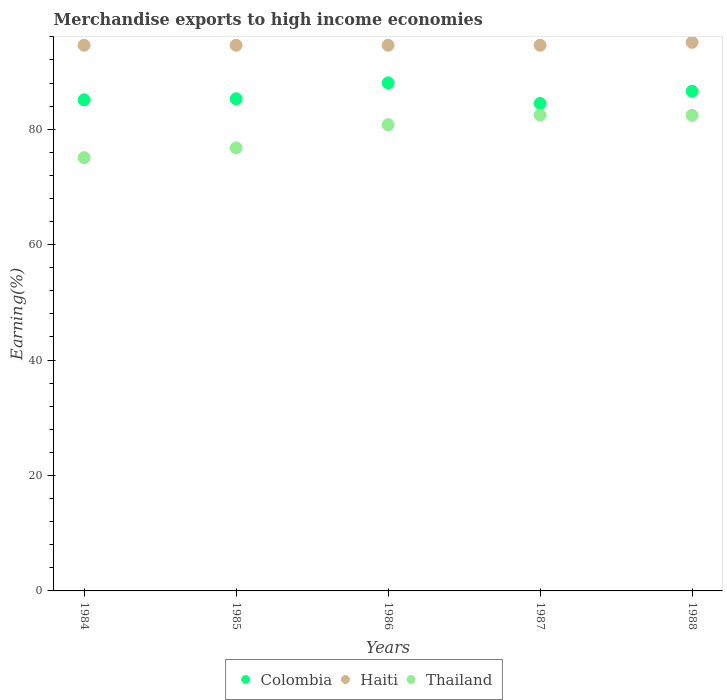How many different coloured dotlines are there?
Provide a short and direct response. 3. What is the percentage of amount earned from merchandise exports in Thailand in 1984?
Offer a terse response. 75.07. Across all years, what is the maximum percentage of amount earned from merchandise exports in Colombia?
Provide a short and direct response. 88.04. Across all years, what is the minimum percentage of amount earned from merchandise exports in Thailand?
Give a very brief answer. 75.07. What is the total percentage of amount earned from merchandise exports in Haiti in the graph?
Ensure brevity in your answer.  473.26. What is the difference between the percentage of amount earned from merchandise exports in Thailand in 1985 and that in 1986?
Provide a succinct answer. -4.02. What is the difference between the percentage of amount earned from merchandise exports in Thailand in 1984 and the percentage of amount earned from merchandise exports in Haiti in 1988?
Your response must be concise. -19.98. What is the average percentage of amount earned from merchandise exports in Colombia per year?
Give a very brief answer. 85.89. In the year 1987, what is the difference between the percentage of amount earned from merchandise exports in Colombia and percentage of amount earned from merchandise exports in Thailand?
Provide a short and direct response. 2.02. What is the ratio of the percentage of amount earned from merchandise exports in Thailand in 1984 to that in 1985?
Give a very brief answer. 0.98. Is the percentage of amount earned from merchandise exports in Thailand in 1984 less than that in 1987?
Offer a very short reply. Yes. Is the difference between the percentage of amount earned from merchandise exports in Colombia in 1984 and 1988 greater than the difference between the percentage of amount earned from merchandise exports in Thailand in 1984 and 1988?
Offer a very short reply. Yes. What is the difference between the highest and the second highest percentage of amount earned from merchandise exports in Haiti?
Ensure brevity in your answer.  0.5. What is the difference between the highest and the lowest percentage of amount earned from merchandise exports in Colombia?
Keep it short and to the point. 3.57. In how many years, is the percentage of amount earned from merchandise exports in Colombia greater than the average percentage of amount earned from merchandise exports in Colombia taken over all years?
Offer a terse response. 2. Is the percentage of amount earned from merchandise exports in Thailand strictly less than the percentage of amount earned from merchandise exports in Colombia over the years?
Your answer should be compact. Yes. How many dotlines are there?
Offer a terse response. 3. How many years are there in the graph?
Keep it short and to the point. 5. What is the difference between two consecutive major ticks on the Y-axis?
Offer a very short reply. 20. Are the values on the major ticks of Y-axis written in scientific E-notation?
Keep it short and to the point. No. Does the graph contain grids?
Give a very brief answer. No. How many legend labels are there?
Provide a short and direct response. 3. What is the title of the graph?
Your response must be concise. Merchandise exports to high income economies. What is the label or title of the Y-axis?
Offer a very short reply. Earning(%). What is the Earning(%) in Colombia in 1984?
Offer a terse response. 85.1. What is the Earning(%) of Haiti in 1984?
Provide a short and direct response. 94.55. What is the Earning(%) of Thailand in 1984?
Offer a terse response. 75.07. What is the Earning(%) of Colombia in 1985?
Your answer should be very brief. 85.28. What is the Earning(%) in Haiti in 1985?
Offer a terse response. 94.55. What is the Earning(%) in Thailand in 1985?
Give a very brief answer. 76.77. What is the Earning(%) in Colombia in 1986?
Your answer should be compact. 88.04. What is the Earning(%) of Haiti in 1986?
Your answer should be compact. 94.55. What is the Earning(%) of Thailand in 1986?
Offer a very short reply. 80.78. What is the Earning(%) in Colombia in 1987?
Give a very brief answer. 84.47. What is the Earning(%) in Haiti in 1987?
Offer a terse response. 94.55. What is the Earning(%) in Thailand in 1987?
Give a very brief answer. 82.44. What is the Earning(%) in Colombia in 1988?
Your answer should be compact. 86.57. What is the Earning(%) of Haiti in 1988?
Offer a very short reply. 95.05. What is the Earning(%) in Thailand in 1988?
Provide a succinct answer. 82.4. Across all years, what is the maximum Earning(%) in Colombia?
Your answer should be compact. 88.04. Across all years, what is the maximum Earning(%) in Haiti?
Your answer should be very brief. 95.05. Across all years, what is the maximum Earning(%) in Thailand?
Provide a short and direct response. 82.44. Across all years, what is the minimum Earning(%) of Colombia?
Offer a terse response. 84.47. Across all years, what is the minimum Earning(%) in Haiti?
Keep it short and to the point. 94.55. Across all years, what is the minimum Earning(%) in Thailand?
Your answer should be very brief. 75.07. What is the total Earning(%) in Colombia in the graph?
Your answer should be compact. 429.45. What is the total Earning(%) in Haiti in the graph?
Give a very brief answer. 473.26. What is the total Earning(%) of Thailand in the graph?
Ensure brevity in your answer.  397.47. What is the difference between the Earning(%) in Colombia in 1984 and that in 1985?
Give a very brief answer. -0.18. What is the difference between the Earning(%) in Thailand in 1984 and that in 1985?
Make the answer very short. -1.69. What is the difference between the Earning(%) of Colombia in 1984 and that in 1986?
Your answer should be compact. -2.94. What is the difference between the Earning(%) in Haiti in 1984 and that in 1986?
Keep it short and to the point. 0. What is the difference between the Earning(%) in Thailand in 1984 and that in 1986?
Keep it short and to the point. -5.71. What is the difference between the Earning(%) of Colombia in 1984 and that in 1987?
Offer a very short reply. 0.63. What is the difference between the Earning(%) in Haiti in 1984 and that in 1987?
Give a very brief answer. 0. What is the difference between the Earning(%) in Thailand in 1984 and that in 1987?
Give a very brief answer. -7.37. What is the difference between the Earning(%) of Colombia in 1984 and that in 1988?
Offer a very short reply. -1.47. What is the difference between the Earning(%) in Haiti in 1984 and that in 1988?
Make the answer very short. -0.5. What is the difference between the Earning(%) of Thailand in 1984 and that in 1988?
Your answer should be very brief. -7.33. What is the difference between the Earning(%) of Colombia in 1985 and that in 1986?
Offer a very short reply. -2.76. What is the difference between the Earning(%) in Thailand in 1985 and that in 1986?
Your response must be concise. -4.02. What is the difference between the Earning(%) in Colombia in 1985 and that in 1987?
Your answer should be very brief. 0.81. What is the difference between the Earning(%) of Thailand in 1985 and that in 1987?
Offer a very short reply. -5.68. What is the difference between the Earning(%) of Colombia in 1985 and that in 1988?
Provide a succinct answer. -1.3. What is the difference between the Earning(%) in Haiti in 1985 and that in 1988?
Keep it short and to the point. -0.5. What is the difference between the Earning(%) of Thailand in 1985 and that in 1988?
Offer a terse response. -5.64. What is the difference between the Earning(%) of Colombia in 1986 and that in 1987?
Your answer should be very brief. 3.57. What is the difference between the Earning(%) of Thailand in 1986 and that in 1987?
Offer a terse response. -1.66. What is the difference between the Earning(%) of Colombia in 1986 and that in 1988?
Your answer should be very brief. 1.46. What is the difference between the Earning(%) in Haiti in 1986 and that in 1988?
Keep it short and to the point. -0.5. What is the difference between the Earning(%) in Thailand in 1986 and that in 1988?
Offer a very short reply. -1.62. What is the difference between the Earning(%) in Colombia in 1987 and that in 1988?
Make the answer very short. -2.11. What is the difference between the Earning(%) in Haiti in 1987 and that in 1988?
Provide a succinct answer. -0.5. What is the difference between the Earning(%) in Colombia in 1984 and the Earning(%) in Haiti in 1985?
Offer a very short reply. -9.45. What is the difference between the Earning(%) in Colombia in 1984 and the Earning(%) in Thailand in 1985?
Keep it short and to the point. 8.34. What is the difference between the Earning(%) of Haiti in 1984 and the Earning(%) of Thailand in 1985?
Your response must be concise. 17.79. What is the difference between the Earning(%) in Colombia in 1984 and the Earning(%) in Haiti in 1986?
Ensure brevity in your answer.  -9.45. What is the difference between the Earning(%) of Colombia in 1984 and the Earning(%) of Thailand in 1986?
Provide a succinct answer. 4.32. What is the difference between the Earning(%) of Haiti in 1984 and the Earning(%) of Thailand in 1986?
Make the answer very short. 13.77. What is the difference between the Earning(%) of Colombia in 1984 and the Earning(%) of Haiti in 1987?
Make the answer very short. -9.45. What is the difference between the Earning(%) in Colombia in 1984 and the Earning(%) in Thailand in 1987?
Provide a succinct answer. 2.66. What is the difference between the Earning(%) of Haiti in 1984 and the Earning(%) of Thailand in 1987?
Your answer should be very brief. 12.11. What is the difference between the Earning(%) in Colombia in 1984 and the Earning(%) in Haiti in 1988?
Your answer should be very brief. -9.95. What is the difference between the Earning(%) of Colombia in 1984 and the Earning(%) of Thailand in 1988?
Give a very brief answer. 2.7. What is the difference between the Earning(%) of Haiti in 1984 and the Earning(%) of Thailand in 1988?
Give a very brief answer. 12.15. What is the difference between the Earning(%) in Colombia in 1985 and the Earning(%) in Haiti in 1986?
Make the answer very short. -9.28. What is the difference between the Earning(%) of Colombia in 1985 and the Earning(%) of Thailand in 1986?
Offer a very short reply. 4.49. What is the difference between the Earning(%) of Haiti in 1985 and the Earning(%) of Thailand in 1986?
Keep it short and to the point. 13.77. What is the difference between the Earning(%) in Colombia in 1985 and the Earning(%) in Haiti in 1987?
Your answer should be compact. -9.28. What is the difference between the Earning(%) in Colombia in 1985 and the Earning(%) in Thailand in 1987?
Provide a succinct answer. 2.83. What is the difference between the Earning(%) in Haiti in 1985 and the Earning(%) in Thailand in 1987?
Keep it short and to the point. 12.11. What is the difference between the Earning(%) in Colombia in 1985 and the Earning(%) in Haiti in 1988?
Offer a very short reply. -9.78. What is the difference between the Earning(%) of Colombia in 1985 and the Earning(%) of Thailand in 1988?
Offer a very short reply. 2.87. What is the difference between the Earning(%) of Haiti in 1985 and the Earning(%) of Thailand in 1988?
Offer a terse response. 12.15. What is the difference between the Earning(%) of Colombia in 1986 and the Earning(%) of Haiti in 1987?
Your answer should be compact. -6.52. What is the difference between the Earning(%) in Colombia in 1986 and the Earning(%) in Thailand in 1987?
Give a very brief answer. 5.59. What is the difference between the Earning(%) of Haiti in 1986 and the Earning(%) of Thailand in 1987?
Your response must be concise. 12.11. What is the difference between the Earning(%) of Colombia in 1986 and the Earning(%) of Haiti in 1988?
Make the answer very short. -7.02. What is the difference between the Earning(%) in Colombia in 1986 and the Earning(%) in Thailand in 1988?
Ensure brevity in your answer.  5.63. What is the difference between the Earning(%) in Haiti in 1986 and the Earning(%) in Thailand in 1988?
Provide a short and direct response. 12.15. What is the difference between the Earning(%) in Colombia in 1987 and the Earning(%) in Haiti in 1988?
Ensure brevity in your answer.  -10.59. What is the difference between the Earning(%) in Colombia in 1987 and the Earning(%) in Thailand in 1988?
Your answer should be compact. 2.06. What is the difference between the Earning(%) in Haiti in 1987 and the Earning(%) in Thailand in 1988?
Keep it short and to the point. 12.15. What is the average Earning(%) of Colombia per year?
Your response must be concise. 85.89. What is the average Earning(%) in Haiti per year?
Keep it short and to the point. 94.65. What is the average Earning(%) of Thailand per year?
Keep it short and to the point. 79.49. In the year 1984, what is the difference between the Earning(%) of Colombia and Earning(%) of Haiti?
Keep it short and to the point. -9.45. In the year 1984, what is the difference between the Earning(%) in Colombia and Earning(%) in Thailand?
Offer a terse response. 10.03. In the year 1984, what is the difference between the Earning(%) in Haiti and Earning(%) in Thailand?
Give a very brief answer. 19.48. In the year 1985, what is the difference between the Earning(%) of Colombia and Earning(%) of Haiti?
Ensure brevity in your answer.  -9.28. In the year 1985, what is the difference between the Earning(%) of Colombia and Earning(%) of Thailand?
Keep it short and to the point. 8.51. In the year 1985, what is the difference between the Earning(%) in Haiti and Earning(%) in Thailand?
Provide a succinct answer. 17.79. In the year 1986, what is the difference between the Earning(%) of Colombia and Earning(%) of Haiti?
Your answer should be compact. -6.52. In the year 1986, what is the difference between the Earning(%) in Colombia and Earning(%) in Thailand?
Your answer should be very brief. 7.25. In the year 1986, what is the difference between the Earning(%) in Haiti and Earning(%) in Thailand?
Give a very brief answer. 13.77. In the year 1987, what is the difference between the Earning(%) of Colombia and Earning(%) of Haiti?
Make the answer very short. -10.09. In the year 1987, what is the difference between the Earning(%) in Colombia and Earning(%) in Thailand?
Offer a very short reply. 2.02. In the year 1987, what is the difference between the Earning(%) in Haiti and Earning(%) in Thailand?
Offer a terse response. 12.11. In the year 1988, what is the difference between the Earning(%) in Colombia and Earning(%) in Haiti?
Ensure brevity in your answer.  -8.48. In the year 1988, what is the difference between the Earning(%) of Colombia and Earning(%) of Thailand?
Provide a short and direct response. 4.17. In the year 1988, what is the difference between the Earning(%) of Haiti and Earning(%) of Thailand?
Your answer should be very brief. 12.65. What is the ratio of the Earning(%) of Colombia in 1984 to that in 1986?
Offer a very short reply. 0.97. What is the ratio of the Earning(%) of Thailand in 1984 to that in 1986?
Give a very brief answer. 0.93. What is the ratio of the Earning(%) of Colombia in 1984 to that in 1987?
Offer a terse response. 1.01. What is the ratio of the Earning(%) in Haiti in 1984 to that in 1987?
Make the answer very short. 1. What is the ratio of the Earning(%) of Thailand in 1984 to that in 1987?
Your answer should be compact. 0.91. What is the ratio of the Earning(%) of Colombia in 1984 to that in 1988?
Make the answer very short. 0.98. What is the ratio of the Earning(%) of Thailand in 1984 to that in 1988?
Offer a terse response. 0.91. What is the ratio of the Earning(%) of Colombia in 1985 to that in 1986?
Make the answer very short. 0.97. What is the ratio of the Earning(%) in Haiti in 1985 to that in 1986?
Give a very brief answer. 1. What is the ratio of the Earning(%) of Thailand in 1985 to that in 1986?
Your answer should be compact. 0.95. What is the ratio of the Earning(%) in Colombia in 1985 to that in 1987?
Your answer should be very brief. 1.01. What is the ratio of the Earning(%) of Haiti in 1985 to that in 1987?
Your answer should be compact. 1. What is the ratio of the Earning(%) of Thailand in 1985 to that in 1987?
Ensure brevity in your answer.  0.93. What is the ratio of the Earning(%) of Colombia in 1985 to that in 1988?
Provide a succinct answer. 0.98. What is the ratio of the Earning(%) in Thailand in 1985 to that in 1988?
Provide a succinct answer. 0.93. What is the ratio of the Earning(%) in Colombia in 1986 to that in 1987?
Make the answer very short. 1.04. What is the ratio of the Earning(%) in Haiti in 1986 to that in 1987?
Ensure brevity in your answer.  1. What is the ratio of the Earning(%) in Thailand in 1986 to that in 1987?
Your answer should be compact. 0.98. What is the ratio of the Earning(%) of Colombia in 1986 to that in 1988?
Provide a short and direct response. 1.02. What is the ratio of the Earning(%) in Thailand in 1986 to that in 1988?
Provide a succinct answer. 0.98. What is the ratio of the Earning(%) in Colombia in 1987 to that in 1988?
Ensure brevity in your answer.  0.98. What is the ratio of the Earning(%) in Haiti in 1987 to that in 1988?
Make the answer very short. 0.99. What is the ratio of the Earning(%) of Thailand in 1987 to that in 1988?
Give a very brief answer. 1. What is the difference between the highest and the second highest Earning(%) of Colombia?
Your answer should be very brief. 1.46. What is the difference between the highest and the second highest Earning(%) in Haiti?
Your answer should be compact. 0.5. What is the difference between the highest and the second highest Earning(%) of Thailand?
Provide a short and direct response. 0.04. What is the difference between the highest and the lowest Earning(%) of Colombia?
Your answer should be compact. 3.57. What is the difference between the highest and the lowest Earning(%) in Haiti?
Offer a very short reply. 0.5. What is the difference between the highest and the lowest Earning(%) of Thailand?
Provide a short and direct response. 7.37. 